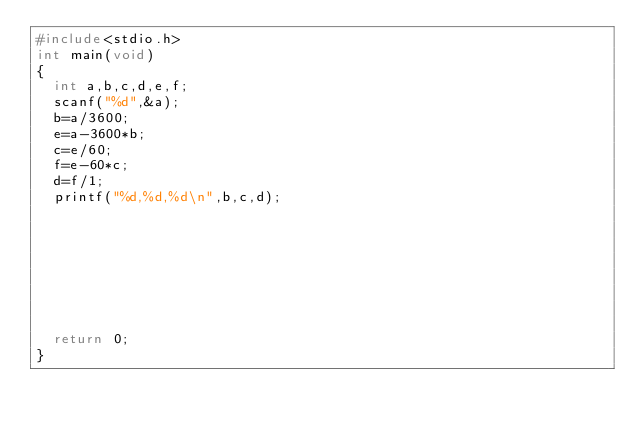Convert code to text. <code><loc_0><loc_0><loc_500><loc_500><_C_>#include<stdio.h>
int main(void)
{
	int a,b,c,d,e,f;
	scanf("%d",&a);
	b=a/3600;
	e=a-3600*b;
	c=e/60;
	f=e-60*c;
	d=f/1;
	printf("%d,%d,%d\n",b,c,d);
	
	
	
	
	
	
	
	
	return 0;
}
</code> 